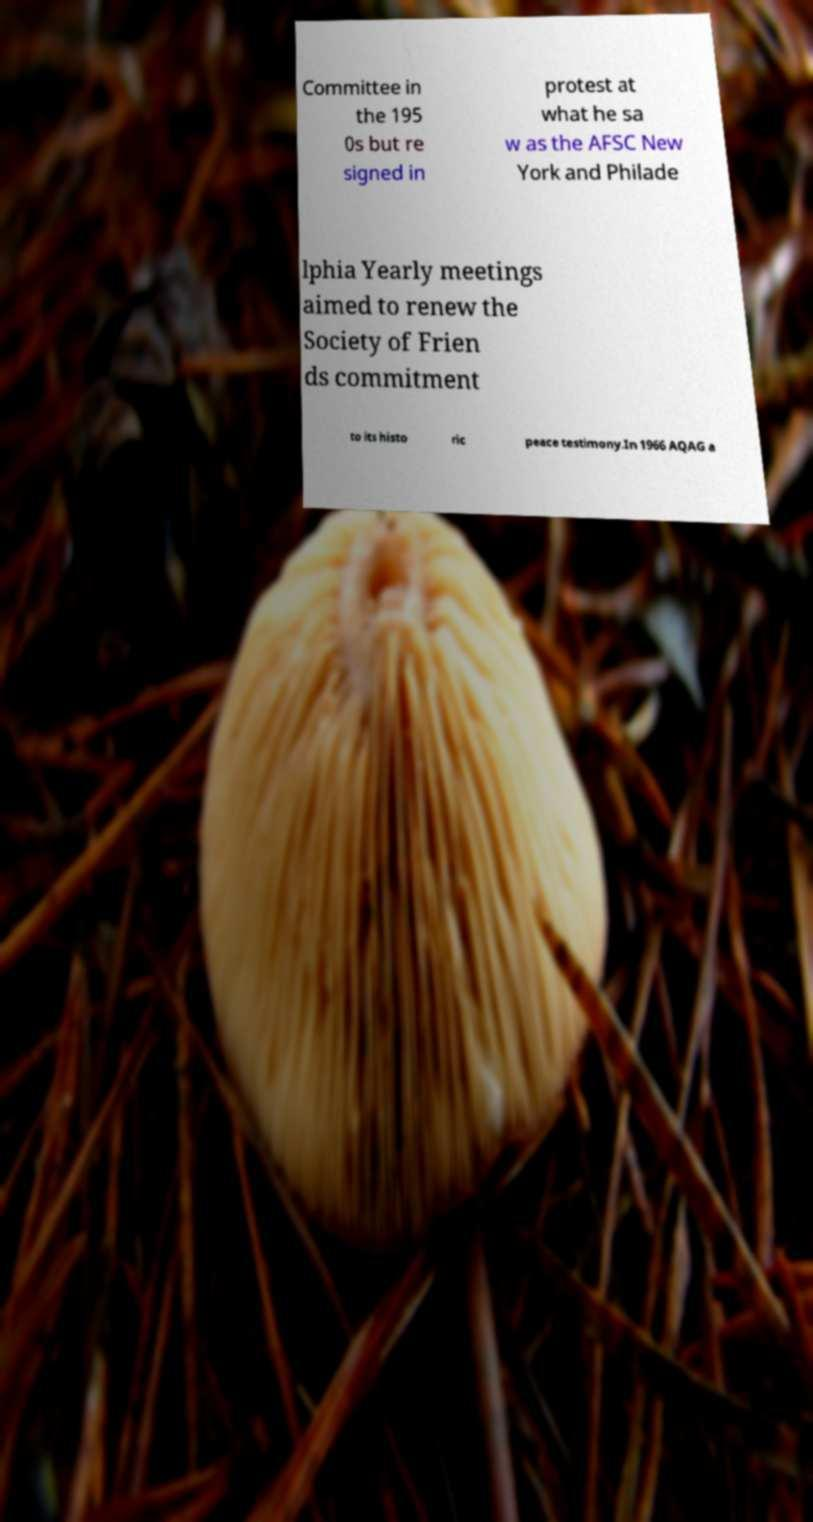What messages or text are displayed in this image? I need them in a readable, typed format. Committee in the 195 0s but re signed in protest at what he sa w as the AFSC New York and Philade lphia Yearly meetings aimed to renew the Society of Frien ds commitment to its histo ric peace testimony.In 1966 AQAG a 